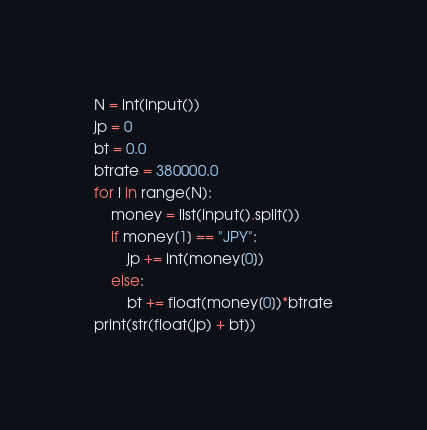<code> <loc_0><loc_0><loc_500><loc_500><_Python_>N = int(input())
jp = 0
bt = 0.0
btrate = 380000.0
for i in range(N):
    money = list(input().split())
    if money[1] == "JPY":
        jp += int(money[0])
    else:
        bt += float(money[0])*btrate
print(str(float(jp) + bt))</code> 